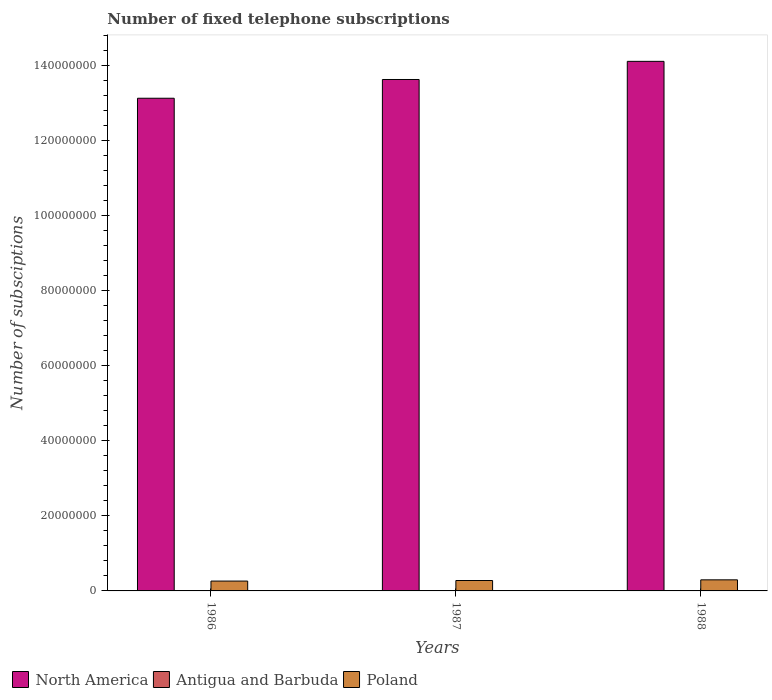How many different coloured bars are there?
Keep it short and to the point. 3. How many groups of bars are there?
Give a very brief answer. 3. How many bars are there on the 2nd tick from the right?
Ensure brevity in your answer.  3. In how many cases, is the number of bars for a given year not equal to the number of legend labels?
Your response must be concise. 0. What is the number of fixed telephone subscriptions in Poland in 1988?
Keep it short and to the point. 2.95e+06. Across all years, what is the maximum number of fixed telephone subscriptions in Poland?
Offer a very short reply. 2.95e+06. Across all years, what is the minimum number of fixed telephone subscriptions in North America?
Offer a terse response. 1.31e+08. In which year was the number of fixed telephone subscriptions in Poland maximum?
Provide a short and direct response. 1988. What is the total number of fixed telephone subscriptions in Antigua and Barbuda in the graph?
Your answer should be compact. 2.85e+04. What is the difference between the number of fixed telephone subscriptions in North America in 1987 and that in 1988?
Offer a very short reply. -4.83e+06. What is the difference between the number of fixed telephone subscriptions in Poland in 1986 and the number of fixed telephone subscriptions in Antigua and Barbuda in 1987?
Make the answer very short. 2.62e+06. What is the average number of fixed telephone subscriptions in Poland per year?
Your answer should be compact. 2.78e+06. In the year 1988, what is the difference between the number of fixed telephone subscriptions in Antigua and Barbuda and number of fixed telephone subscriptions in North America?
Give a very brief answer. -1.41e+08. In how many years, is the number of fixed telephone subscriptions in Poland greater than 40000000?
Provide a succinct answer. 0. What is the ratio of the number of fixed telephone subscriptions in North America in 1986 to that in 1988?
Offer a very short reply. 0.93. Is the difference between the number of fixed telephone subscriptions in Antigua and Barbuda in 1987 and 1988 greater than the difference between the number of fixed telephone subscriptions in North America in 1987 and 1988?
Make the answer very short. Yes. What is the difference between the highest and the second highest number of fixed telephone subscriptions in Poland?
Offer a terse response. 1.78e+05. What is the difference between the highest and the lowest number of fixed telephone subscriptions in North America?
Your answer should be compact. 9.83e+06. In how many years, is the number of fixed telephone subscriptions in Antigua and Barbuda greater than the average number of fixed telephone subscriptions in Antigua and Barbuda taken over all years?
Offer a terse response. 1. Is the sum of the number of fixed telephone subscriptions in Antigua and Barbuda in 1986 and 1988 greater than the maximum number of fixed telephone subscriptions in North America across all years?
Make the answer very short. No. What does the 1st bar from the left in 1987 represents?
Give a very brief answer. North America. What does the 3rd bar from the right in 1986 represents?
Provide a succinct answer. North America. Is it the case that in every year, the sum of the number of fixed telephone subscriptions in Antigua and Barbuda and number of fixed telephone subscriptions in North America is greater than the number of fixed telephone subscriptions in Poland?
Make the answer very short. Yes. Are all the bars in the graph horizontal?
Give a very brief answer. No. How many years are there in the graph?
Give a very brief answer. 3. Does the graph contain any zero values?
Keep it short and to the point. No. Does the graph contain grids?
Provide a short and direct response. No. Where does the legend appear in the graph?
Ensure brevity in your answer.  Bottom left. How many legend labels are there?
Give a very brief answer. 3. How are the legend labels stacked?
Make the answer very short. Horizontal. What is the title of the graph?
Keep it short and to the point. Number of fixed telephone subscriptions. What is the label or title of the Y-axis?
Your response must be concise. Number of subsciptions. What is the Number of subsciptions in North America in 1986?
Make the answer very short. 1.31e+08. What is the Number of subsciptions in Antigua and Barbuda in 1986?
Give a very brief answer. 8000. What is the Number of subsciptions in Poland in 1986?
Provide a short and direct response. 2.63e+06. What is the Number of subsciptions of North America in 1987?
Offer a very short reply. 1.36e+08. What is the Number of subsciptions of Antigua and Barbuda in 1987?
Ensure brevity in your answer.  9500. What is the Number of subsciptions in Poland in 1987?
Offer a terse response. 2.77e+06. What is the Number of subsciptions of North America in 1988?
Make the answer very short. 1.41e+08. What is the Number of subsciptions in Antigua and Barbuda in 1988?
Ensure brevity in your answer.  1.10e+04. What is the Number of subsciptions of Poland in 1988?
Your response must be concise. 2.95e+06. Across all years, what is the maximum Number of subsciptions in North America?
Offer a very short reply. 1.41e+08. Across all years, what is the maximum Number of subsciptions in Antigua and Barbuda?
Your answer should be very brief. 1.10e+04. Across all years, what is the maximum Number of subsciptions of Poland?
Provide a short and direct response. 2.95e+06. Across all years, what is the minimum Number of subsciptions of North America?
Make the answer very short. 1.31e+08. Across all years, what is the minimum Number of subsciptions of Antigua and Barbuda?
Your answer should be very brief. 8000. Across all years, what is the minimum Number of subsciptions in Poland?
Offer a very short reply. 2.63e+06. What is the total Number of subsciptions of North America in the graph?
Provide a short and direct response. 4.09e+08. What is the total Number of subsciptions in Antigua and Barbuda in the graph?
Your answer should be compact. 2.85e+04. What is the total Number of subsciptions of Poland in the graph?
Make the answer very short. 8.35e+06. What is the difference between the Number of subsciptions in North America in 1986 and that in 1987?
Offer a terse response. -5.00e+06. What is the difference between the Number of subsciptions in Antigua and Barbuda in 1986 and that in 1987?
Ensure brevity in your answer.  -1500. What is the difference between the Number of subsciptions in Poland in 1986 and that in 1987?
Ensure brevity in your answer.  -1.49e+05. What is the difference between the Number of subsciptions in North America in 1986 and that in 1988?
Give a very brief answer. -9.83e+06. What is the difference between the Number of subsciptions in Antigua and Barbuda in 1986 and that in 1988?
Ensure brevity in your answer.  -3000. What is the difference between the Number of subsciptions in Poland in 1986 and that in 1988?
Give a very brief answer. -3.28e+05. What is the difference between the Number of subsciptions of North America in 1987 and that in 1988?
Offer a very short reply. -4.83e+06. What is the difference between the Number of subsciptions in Antigua and Barbuda in 1987 and that in 1988?
Make the answer very short. -1500. What is the difference between the Number of subsciptions in Poland in 1987 and that in 1988?
Provide a succinct answer. -1.78e+05. What is the difference between the Number of subsciptions in North America in 1986 and the Number of subsciptions in Antigua and Barbuda in 1987?
Your response must be concise. 1.31e+08. What is the difference between the Number of subsciptions of North America in 1986 and the Number of subsciptions of Poland in 1987?
Your answer should be compact. 1.28e+08. What is the difference between the Number of subsciptions in Antigua and Barbuda in 1986 and the Number of subsciptions in Poland in 1987?
Provide a short and direct response. -2.77e+06. What is the difference between the Number of subsciptions in North America in 1986 and the Number of subsciptions in Antigua and Barbuda in 1988?
Give a very brief answer. 1.31e+08. What is the difference between the Number of subsciptions in North America in 1986 and the Number of subsciptions in Poland in 1988?
Offer a terse response. 1.28e+08. What is the difference between the Number of subsciptions of Antigua and Barbuda in 1986 and the Number of subsciptions of Poland in 1988?
Keep it short and to the point. -2.94e+06. What is the difference between the Number of subsciptions of North America in 1987 and the Number of subsciptions of Antigua and Barbuda in 1988?
Your response must be concise. 1.36e+08. What is the difference between the Number of subsciptions in North America in 1987 and the Number of subsciptions in Poland in 1988?
Provide a succinct answer. 1.33e+08. What is the difference between the Number of subsciptions of Antigua and Barbuda in 1987 and the Number of subsciptions of Poland in 1988?
Ensure brevity in your answer.  -2.94e+06. What is the average Number of subsciptions in North America per year?
Offer a terse response. 1.36e+08. What is the average Number of subsciptions in Antigua and Barbuda per year?
Keep it short and to the point. 9500. What is the average Number of subsciptions in Poland per year?
Offer a terse response. 2.78e+06. In the year 1986, what is the difference between the Number of subsciptions in North America and Number of subsciptions in Antigua and Barbuda?
Provide a succinct answer. 1.31e+08. In the year 1986, what is the difference between the Number of subsciptions of North America and Number of subsciptions of Poland?
Provide a succinct answer. 1.29e+08. In the year 1986, what is the difference between the Number of subsciptions of Antigua and Barbuda and Number of subsciptions of Poland?
Provide a succinct answer. -2.62e+06. In the year 1987, what is the difference between the Number of subsciptions in North America and Number of subsciptions in Antigua and Barbuda?
Keep it short and to the point. 1.36e+08. In the year 1987, what is the difference between the Number of subsciptions of North America and Number of subsciptions of Poland?
Your response must be concise. 1.33e+08. In the year 1987, what is the difference between the Number of subsciptions of Antigua and Barbuda and Number of subsciptions of Poland?
Provide a short and direct response. -2.76e+06. In the year 1988, what is the difference between the Number of subsciptions of North America and Number of subsciptions of Antigua and Barbuda?
Provide a succinct answer. 1.41e+08. In the year 1988, what is the difference between the Number of subsciptions of North America and Number of subsciptions of Poland?
Offer a very short reply. 1.38e+08. In the year 1988, what is the difference between the Number of subsciptions in Antigua and Barbuda and Number of subsciptions in Poland?
Make the answer very short. -2.94e+06. What is the ratio of the Number of subsciptions of North America in 1986 to that in 1987?
Provide a succinct answer. 0.96. What is the ratio of the Number of subsciptions in Antigua and Barbuda in 1986 to that in 1987?
Provide a succinct answer. 0.84. What is the ratio of the Number of subsciptions of Poland in 1986 to that in 1987?
Make the answer very short. 0.95. What is the ratio of the Number of subsciptions of North America in 1986 to that in 1988?
Give a very brief answer. 0.93. What is the ratio of the Number of subsciptions of Antigua and Barbuda in 1986 to that in 1988?
Give a very brief answer. 0.73. What is the ratio of the Number of subsciptions of Poland in 1986 to that in 1988?
Your answer should be compact. 0.89. What is the ratio of the Number of subsciptions in North America in 1987 to that in 1988?
Give a very brief answer. 0.97. What is the ratio of the Number of subsciptions in Antigua and Barbuda in 1987 to that in 1988?
Give a very brief answer. 0.86. What is the ratio of the Number of subsciptions in Poland in 1987 to that in 1988?
Offer a very short reply. 0.94. What is the difference between the highest and the second highest Number of subsciptions in North America?
Provide a succinct answer. 4.83e+06. What is the difference between the highest and the second highest Number of subsciptions of Antigua and Barbuda?
Make the answer very short. 1500. What is the difference between the highest and the second highest Number of subsciptions of Poland?
Offer a terse response. 1.78e+05. What is the difference between the highest and the lowest Number of subsciptions in North America?
Provide a succinct answer. 9.83e+06. What is the difference between the highest and the lowest Number of subsciptions of Antigua and Barbuda?
Provide a succinct answer. 3000. What is the difference between the highest and the lowest Number of subsciptions of Poland?
Make the answer very short. 3.28e+05. 